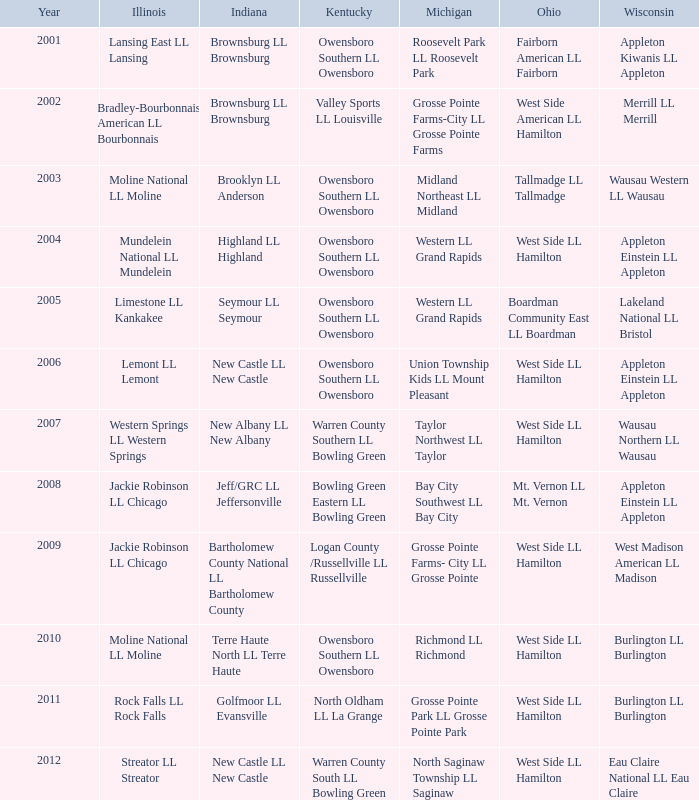What was the little league team from Kentucky when the little league team from Illinois was Rock Falls LL Rock Falls? North Oldham LL La Grange. 